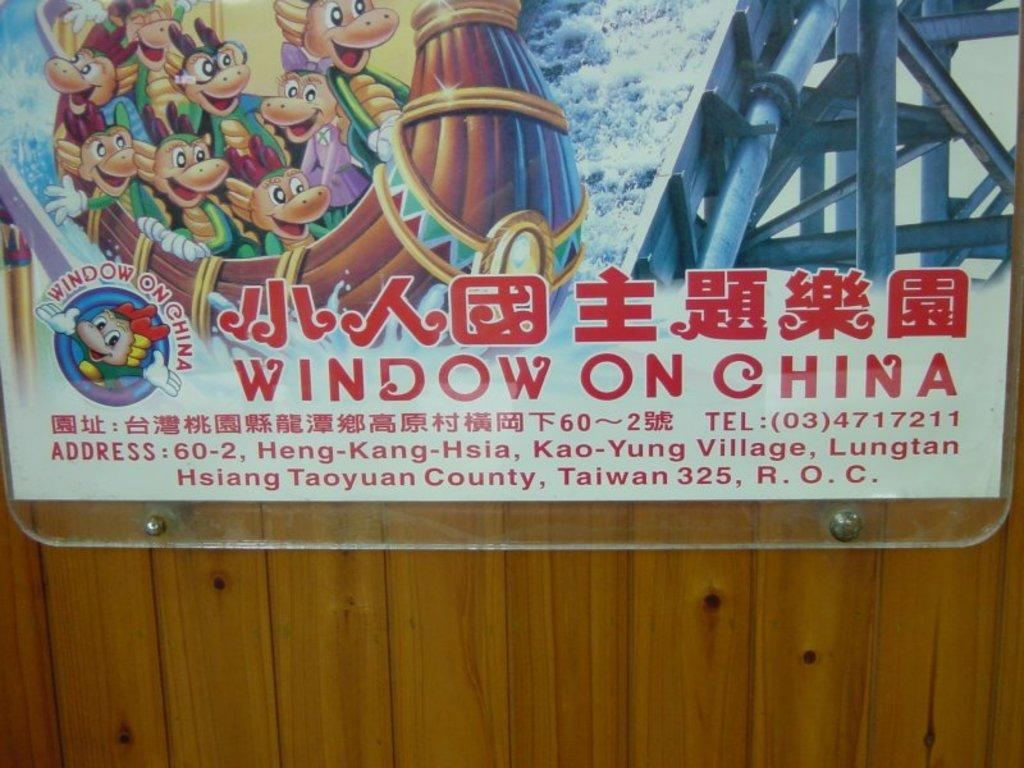<image>
Render a clear and concise summary of the photo. A poster of Window on China behind clear class on a wood paneled wall. 